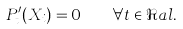<formula> <loc_0><loc_0><loc_500><loc_500>P ^ { \prime } _ { t } ( X _ { i } ) = 0 \quad \forall t \in \Re a l .</formula> 